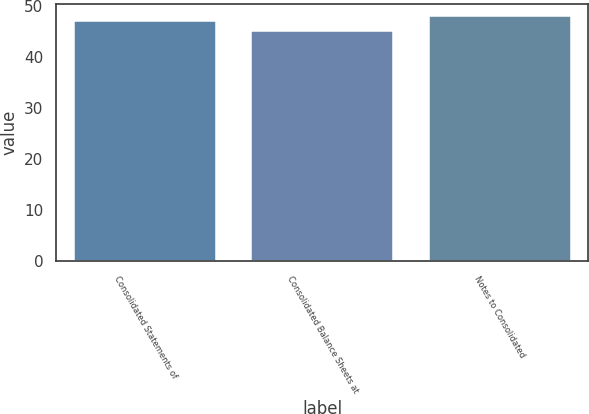Convert chart. <chart><loc_0><loc_0><loc_500><loc_500><bar_chart><fcel>Consolidated Statements of<fcel>Consolidated Balance Sheets at<fcel>Notes to Consolidated<nl><fcel>47<fcel>45<fcel>48<nl></chart> 